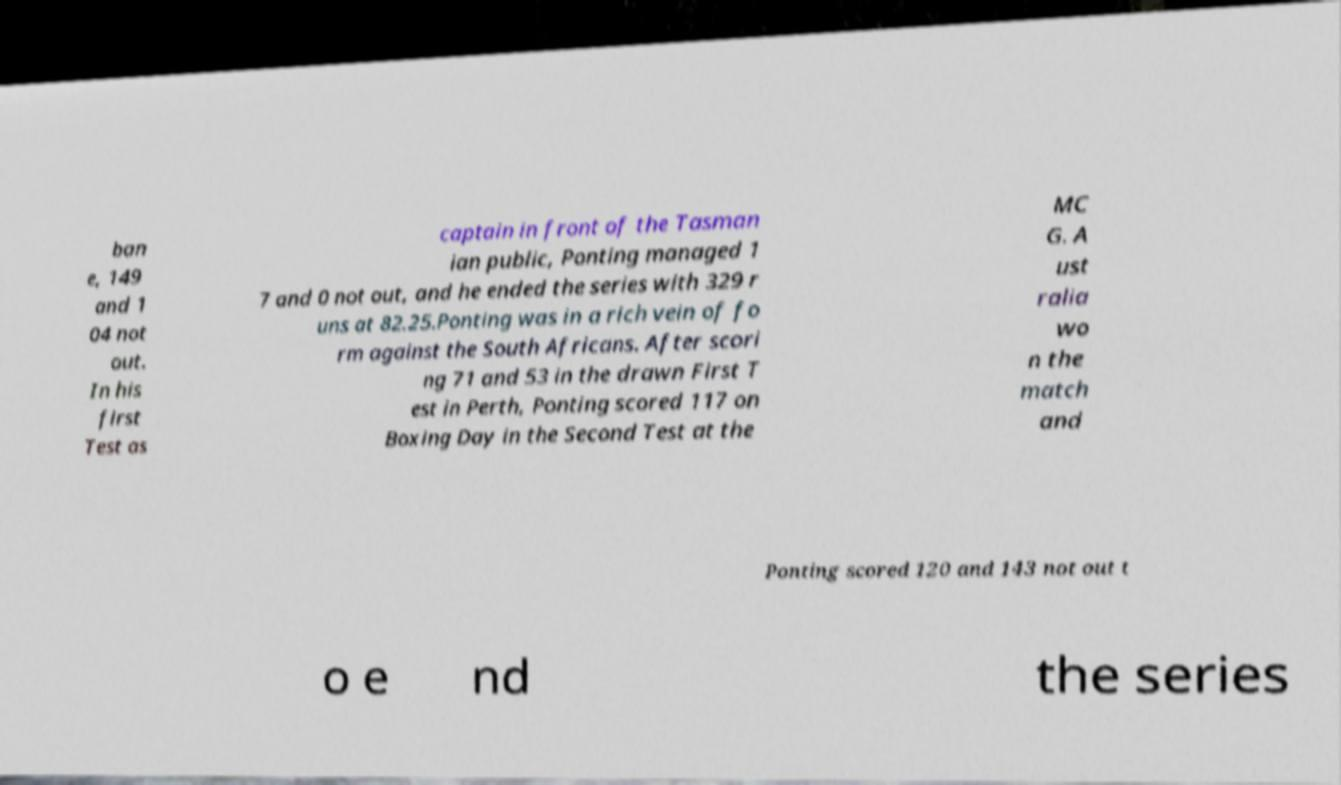There's text embedded in this image that I need extracted. Can you transcribe it verbatim? ban e, 149 and 1 04 not out. In his first Test as captain in front of the Tasman ian public, Ponting managed 1 7 and 0 not out, and he ended the series with 329 r uns at 82.25.Ponting was in a rich vein of fo rm against the South Africans. After scori ng 71 and 53 in the drawn First T est in Perth, Ponting scored 117 on Boxing Day in the Second Test at the MC G. A ust ralia wo n the match and Ponting scored 120 and 143 not out t o e nd the series 